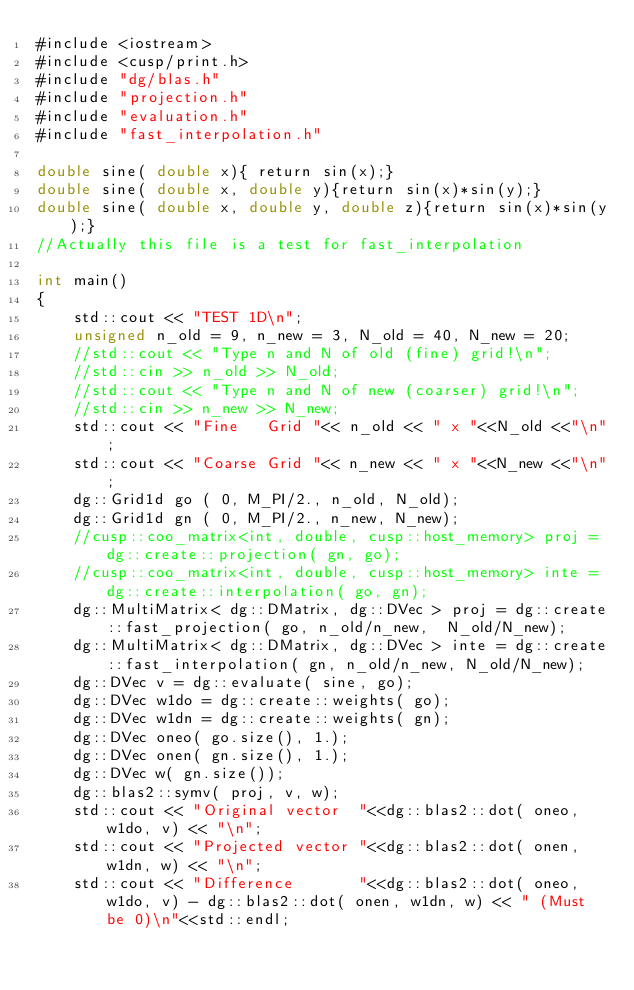<code> <loc_0><loc_0><loc_500><loc_500><_Cuda_>#include <iostream>
#include <cusp/print.h>
#include "dg/blas.h"
#include "projection.h"
#include "evaluation.h"
#include "fast_interpolation.h"

double sine( double x){ return sin(x);}
double sine( double x, double y){return sin(x)*sin(y);}
double sine( double x, double y, double z){return sin(x)*sin(y);}
//Actually this file is a test for fast_interpolation

int main()
{
    std::cout << "TEST 1D\n";
    unsigned n_old = 9, n_new = 3, N_old = 40, N_new = 20;
    //std::cout << "Type n and N of old (fine) grid!\n";
    //std::cin >> n_old >> N_old;
    //std::cout << "Type n and N of new (coarser) grid!\n";
    //std::cin >> n_new >> N_new;
    std::cout << "Fine   Grid "<< n_old << " x "<<N_old <<"\n";
    std::cout << "Coarse Grid "<< n_new << " x "<<N_new <<"\n";
    dg::Grid1d go ( 0, M_PI/2., n_old, N_old);
    dg::Grid1d gn ( 0, M_PI/2., n_new, N_new);
    //cusp::coo_matrix<int, double, cusp::host_memory> proj = dg::create::projection( gn, go);
    //cusp::coo_matrix<int, double, cusp::host_memory> inte = dg::create::interpolation( go, gn);
    dg::MultiMatrix< dg::DMatrix, dg::DVec > proj = dg::create::fast_projection( go, n_old/n_new,  N_old/N_new);
    dg::MultiMatrix< dg::DMatrix, dg::DVec > inte = dg::create::fast_interpolation( gn, n_old/n_new, N_old/N_new);
    dg::DVec v = dg::evaluate( sine, go);
    dg::DVec w1do = dg::create::weights( go);
    dg::DVec w1dn = dg::create::weights( gn);
    dg::DVec oneo( go.size(), 1.);
    dg::DVec onen( gn.size(), 1.);
    dg::DVec w( gn.size());
    dg::blas2::symv( proj, v, w);
    std::cout << "Original vector  "<<dg::blas2::dot( oneo, w1do, v) << "\n";
    std::cout << "Projected vector "<<dg::blas2::dot( onen, w1dn, w) << "\n";
    std::cout << "Difference       "<<dg::blas2::dot( oneo, w1do, v) - dg::blas2::dot( onen, w1dn, w) << " (Must be 0)\n"<<std::endl;</code> 